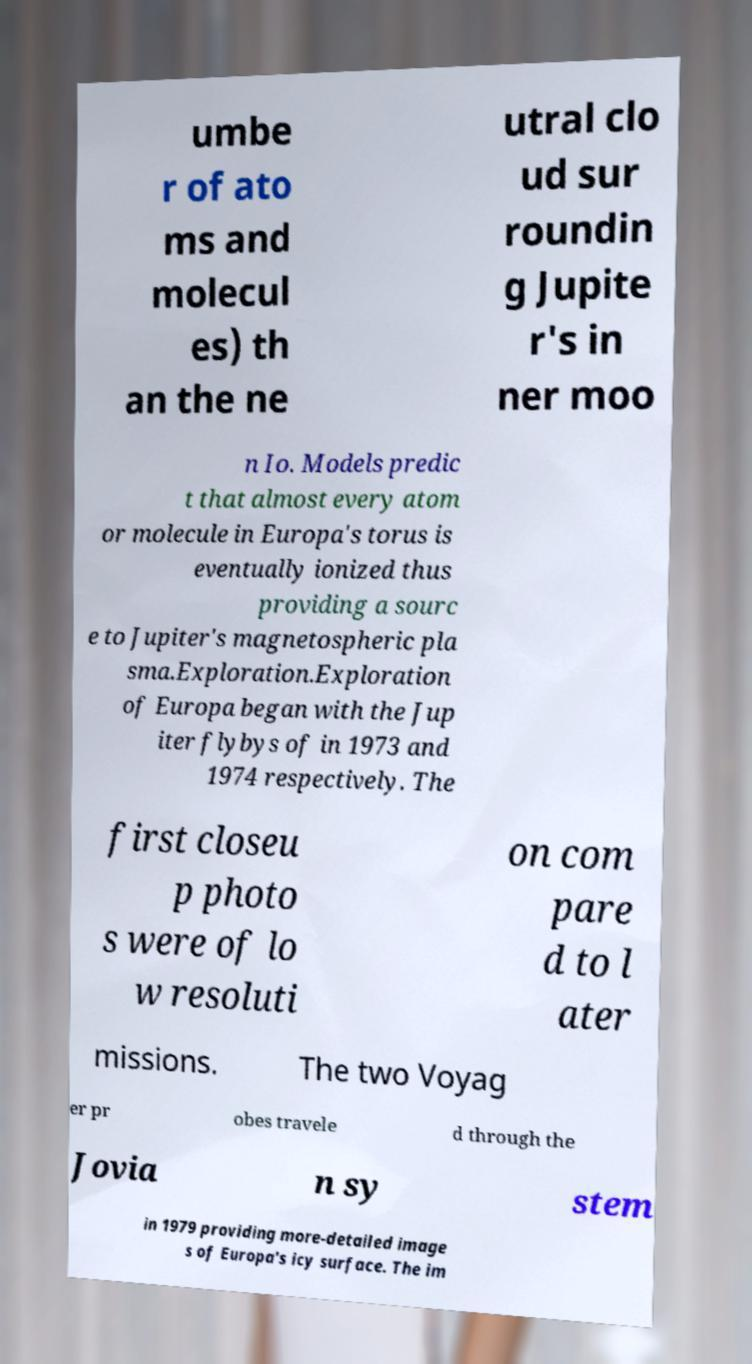Please identify and transcribe the text found in this image. umbe r of ato ms and molecul es) th an the ne utral clo ud sur roundin g Jupite r's in ner moo n Io. Models predic t that almost every atom or molecule in Europa's torus is eventually ionized thus providing a sourc e to Jupiter's magnetospheric pla sma.Exploration.Exploration of Europa began with the Jup iter flybys of in 1973 and 1974 respectively. The first closeu p photo s were of lo w resoluti on com pare d to l ater missions. The two Voyag er pr obes travele d through the Jovia n sy stem in 1979 providing more-detailed image s of Europa's icy surface. The im 